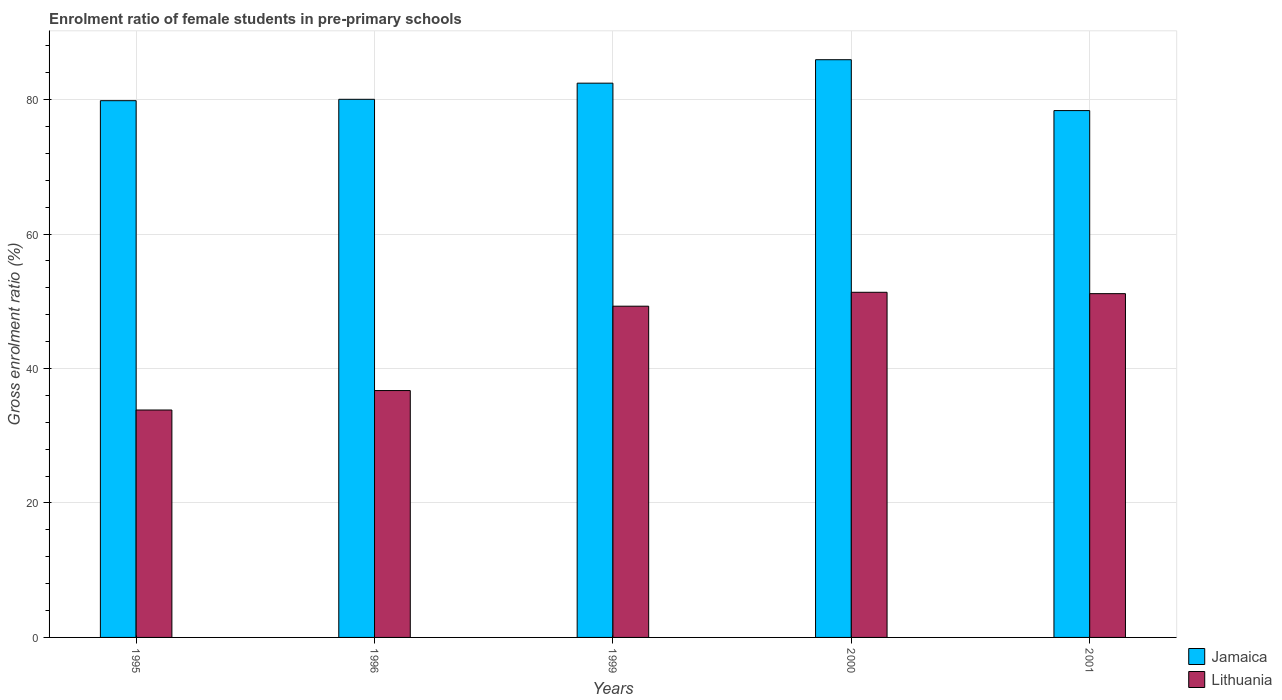How many groups of bars are there?
Offer a terse response. 5. Are the number of bars on each tick of the X-axis equal?
Offer a very short reply. Yes. How many bars are there on the 1st tick from the left?
Offer a terse response. 2. In how many cases, is the number of bars for a given year not equal to the number of legend labels?
Keep it short and to the point. 0. What is the enrolment ratio of female students in pre-primary schools in Lithuania in 1996?
Make the answer very short. 36.72. Across all years, what is the maximum enrolment ratio of female students in pre-primary schools in Jamaica?
Your response must be concise. 85.93. Across all years, what is the minimum enrolment ratio of female students in pre-primary schools in Lithuania?
Provide a short and direct response. 33.83. What is the total enrolment ratio of female students in pre-primary schools in Lithuania in the graph?
Give a very brief answer. 222.28. What is the difference between the enrolment ratio of female students in pre-primary schools in Lithuania in 1995 and that in 2000?
Give a very brief answer. -17.51. What is the difference between the enrolment ratio of female students in pre-primary schools in Jamaica in 2001 and the enrolment ratio of female students in pre-primary schools in Lithuania in 1996?
Offer a very short reply. 41.64. What is the average enrolment ratio of female students in pre-primary schools in Lithuania per year?
Ensure brevity in your answer.  44.46. In the year 1995, what is the difference between the enrolment ratio of female students in pre-primary schools in Jamaica and enrolment ratio of female students in pre-primary schools in Lithuania?
Provide a succinct answer. 46.01. In how many years, is the enrolment ratio of female students in pre-primary schools in Lithuania greater than 24 %?
Your answer should be very brief. 5. What is the ratio of the enrolment ratio of female students in pre-primary schools in Jamaica in 1995 to that in 1999?
Offer a very short reply. 0.97. What is the difference between the highest and the second highest enrolment ratio of female students in pre-primary schools in Jamaica?
Provide a succinct answer. 3.49. What is the difference between the highest and the lowest enrolment ratio of female students in pre-primary schools in Lithuania?
Your answer should be very brief. 17.51. In how many years, is the enrolment ratio of female students in pre-primary schools in Lithuania greater than the average enrolment ratio of female students in pre-primary schools in Lithuania taken over all years?
Provide a succinct answer. 3. Is the sum of the enrolment ratio of female students in pre-primary schools in Jamaica in 1996 and 1999 greater than the maximum enrolment ratio of female students in pre-primary schools in Lithuania across all years?
Your answer should be very brief. Yes. What does the 2nd bar from the left in 2001 represents?
Provide a succinct answer. Lithuania. What does the 1st bar from the right in 2000 represents?
Provide a succinct answer. Lithuania. Does the graph contain any zero values?
Your answer should be very brief. No. Does the graph contain grids?
Your answer should be very brief. Yes. Where does the legend appear in the graph?
Keep it short and to the point. Bottom right. How many legend labels are there?
Your answer should be very brief. 2. What is the title of the graph?
Ensure brevity in your answer.  Enrolment ratio of female students in pre-primary schools. What is the label or title of the X-axis?
Keep it short and to the point. Years. What is the Gross enrolment ratio (%) in Jamaica in 1995?
Offer a terse response. 79.83. What is the Gross enrolment ratio (%) in Lithuania in 1995?
Your answer should be compact. 33.83. What is the Gross enrolment ratio (%) of Jamaica in 1996?
Give a very brief answer. 80.04. What is the Gross enrolment ratio (%) in Lithuania in 1996?
Offer a very short reply. 36.72. What is the Gross enrolment ratio (%) of Jamaica in 1999?
Your answer should be compact. 82.44. What is the Gross enrolment ratio (%) of Lithuania in 1999?
Provide a short and direct response. 49.27. What is the Gross enrolment ratio (%) in Jamaica in 2000?
Your answer should be compact. 85.93. What is the Gross enrolment ratio (%) in Lithuania in 2000?
Ensure brevity in your answer.  51.34. What is the Gross enrolment ratio (%) in Jamaica in 2001?
Provide a succinct answer. 78.36. What is the Gross enrolment ratio (%) of Lithuania in 2001?
Your answer should be compact. 51.13. Across all years, what is the maximum Gross enrolment ratio (%) in Jamaica?
Your response must be concise. 85.93. Across all years, what is the maximum Gross enrolment ratio (%) of Lithuania?
Make the answer very short. 51.34. Across all years, what is the minimum Gross enrolment ratio (%) in Jamaica?
Your answer should be compact. 78.36. Across all years, what is the minimum Gross enrolment ratio (%) of Lithuania?
Ensure brevity in your answer.  33.83. What is the total Gross enrolment ratio (%) of Jamaica in the graph?
Give a very brief answer. 406.6. What is the total Gross enrolment ratio (%) of Lithuania in the graph?
Ensure brevity in your answer.  222.28. What is the difference between the Gross enrolment ratio (%) of Jamaica in 1995 and that in 1996?
Give a very brief answer. -0.21. What is the difference between the Gross enrolment ratio (%) of Lithuania in 1995 and that in 1996?
Offer a terse response. -2.89. What is the difference between the Gross enrolment ratio (%) in Jamaica in 1995 and that in 1999?
Your response must be concise. -2.6. What is the difference between the Gross enrolment ratio (%) in Lithuania in 1995 and that in 1999?
Ensure brevity in your answer.  -15.44. What is the difference between the Gross enrolment ratio (%) in Jamaica in 1995 and that in 2000?
Provide a short and direct response. -6.09. What is the difference between the Gross enrolment ratio (%) of Lithuania in 1995 and that in 2000?
Keep it short and to the point. -17.51. What is the difference between the Gross enrolment ratio (%) of Jamaica in 1995 and that in 2001?
Offer a terse response. 1.47. What is the difference between the Gross enrolment ratio (%) of Lithuania in 1995 and that in 2001?
Provide a short and direct response. -17.31. What is the difference between the Gross enrolment ratio (%) of Jamaica in 1996 and that in 1999?
Keep it short and to the point. -2.4. What is the difference between the Gross enrolment ratio (%) of Lithuania in 1996 and that in 1999?
Offer a terse response. -12.55. What is the difference between the Gross enrolment ratio (%) in Jamaica in 1996 and that in 2000?
Provide a succinct answer. -5.89. What is the difference between the Gross enrolment ratio (%) in Lithuania in 1996 and that in 2000?
Keep it short and to the point. -14.62. What is the difference between the Gross enrolment ratio (%) in Jamaica in 1996 and that in 2001?
Your answer should be very brief. 1.68. What is the difference between the Gross enrolment ratio (%) of Lithuania in 1996 and that in 2001?
Your answer should be compact. -14.42. What is the difference between the Gross enrolment ratio (%) of Jamaica in 1999 and that in 2000?
Provide a succinct answer. -3.49. What is the difference between the Gross enrolment ratio (%) of Lithuania in 1999 and that in 2000?
Offer a terse response. -2.07. What is the difference between the Gross enrolment ratio (%) in Jamaica in 1999 and that in 2001?
Make the answer very short. 4.08. What is the difference between the Gross enrolment ratio (%) in Lithuania in 1999 and that in 2001?
Offer a very short reply. -1.87. What is the difference between the Gross enrolment ratio (%) in Jamaica in 2000 and that in 2001?
Your answer should be very brief. 7.57. What is the difference between the Gross enrolment ratio (%) of Lithuania in 2000 and that in 2001?
Provide a succinct answer. 0.2. What is the difference between the Gross enrolment ratio (%) of Jamaica in 1995 and the Gross enrolment ratio (%) of Lithuania in 1996?
Provide a succinct answer. 43.12. What is the difference between the Gross enrolment ratio (%) of Jamaica in 1995 and the Gross enrolment ratio (%) of Lithuania in 1999?
Your response must be concise. 30.57. What is the difference between the Gross enrolment ratio (%) in Jamaica in 1995 and the Gross enrolment ratio (%) in Lithuania in 2000?
Ensure brevity in your answer.  28.5. What is the difference between the Gross enrolment ratio (%) in Jamaica in 1995 and the Gross enrolment ratio (%) in Lithuania in 2001?
Your response must be concise. 28.7. What is the difference between the Gross enrolment ratio (%) of Jamaica in 1996 and the Gross enrolment ratio (%) of Lithuania in 1999?
Your response must be concise. 30.77. What is the difference between the Gross enrolment ratio (%) of Jamaica in 1996 and the Gross enrolment ratio (%) of Lithuania in 2000?
Offer a very short reply. 28.7. What is the difference between the Gross enrolment ratio (%) in Jamaica in 1996 and the Gross enrolment ratio (%) in Lithuania in 2001?
Offer a very short reply. 28.91. What is the difference between the Gross enrolment ratio (%) of Jamaica in 1999 and the Gross enrolment ratio (%) of Lithuania in 2000?
Provide a short and direct response. 31.1. What is the difference between the Gross enrolment ratio (%) of Jamaica in 1999 and the Gross enrolment ratio (%) of Lithuania in 2001?
Make the answer very short. 31.3. What is the difference between the Gross enrolment ratio (%) of Jamaica in 2000 and the Gross enrolment ratio (%) of Lithuania in 2001?
Keep it short and to the point. 34.79. What is the average Gross enrolment ratio (%) of Jamaica per year?
Ensure brevity in your answer.  81.32. What is the average Gross enrolment ratio (%) in Lithuania per year?
Your response must be concise. 44.46. In the year 1995, what is the difference between the Gross enrolment ratio (%) in Jamaica and Gross enrolment ratio (%) in Lithuania?
Your answer should be compact. 46.01. In the year 1996, what is the difference between the Gross enrolment ratio (%) of Jamaica and Gross enrolment ratio (%) of Lithuania?
Provide a short and direct response. 43.32. In the year 1999, what is the difference between the Gross enrolment ratio (%) in Jamaica and Gross enrolment ratio (%) in Lithuania?
Your answer should be very brief. 33.17. In the year 2000, what is the difference between the Gross enrolment ratio (%) of Jamaica and Gross enrolment ratio (%) of Lithuania?
Keep it short and to the point. 34.59. In the year 2001, what is the difference between the Gross enrolment ratio (%) in Jamaica and Gross enrolment ratio (%) in Lithuania?
Your answer should be very brief. 27.23. What is the ratio of the Gross enrolment ratio (%) in Jamaica in 1995 to that in 1996?
Offer a very short reply. 1. What is the ratio of the Gross enrolment ratio (%) in Lithuania in 1995 to that in 1996?
Your answer should be very brief. 0.92. What is the ratio of the Gross enrolment ratio (%) of Jamaica in 1995 to that in 1999?
Offer a very short reply. 0.97. What is the ratio of the Gross enrolment ratio (%) of Lithuania in 1995 to that in 1999?
Keep it short and to the point. 0.69. What is the ratio of the Gross enrolment ratio (%) of Jamaica in 1995 to that in 2000?
Your response must be concise. 0.93. What is the ratio of the Gross enrolment ratio (%) in Lithuania in 1995 to that in 2000?
Provide a short and direct response. 0.66. What is the ratio of the Gross enrolment ratio (%) in Jamaica in 1995 to that in 2001?
Keep it short and to the point. 1.02. What is the ratio of the Gross enrolment ratio (%) of Lithuania in 1995 to that in 2001?
Offer a very short reply. 0.66. What is the ratio of the Gross enrolment ratio (%) in Jamaica in 1996 to that in 1999?
Your response must be concise. 0.97. What is the ratio of the Gross enrolment ratio (%) in Lithuania in 1996 to that in 1999?
Your answer should be very brief. 0.75. What is the ratio of the Gross enrolment ratio (%) of Jamaica in 1996 to that in 2000?
Your answer should be compact. 0.93. What is the ratio of the Gross enrolment ratio (%) in Lithuania in 1996 to that in 2000?
Your response must be concise. 0.72. What is the ratio of the Gross enrolment ratio (%) in Jamaica in 1996 to that in 2001?
Your response must be concise. 1.02. What is the ratio of the Gross enrolment ratio (%) in Lithuania in 1996 to that in 2001?
Provide a succinct answer. 0.72. What is the ratio of the Gross enrolment ratio (%) in Jamaica in 1999 to that in 2000?
Provide a succinct answer. 0.96. What is the ratio of the Gross enrolment ratio (%) in Lithuania in 1999 to that in 2000?
Offer a very short reply. 0.96. What is the ratio of the Gross enrolment ratio (%) of Jamaica in 1999 to that in 2001?
Offer a terse response. 1.05. What is the ratio of the Gross enrolment ratio (%) of Lithuania in 1999 to that in 2001?
Keep it short and to the point. 0.96. What is the ratio of the Gross enrolment ratio (%) of Jamaica in 2000 to that in 2001?
Make the answer very short. 1.1. What is the difference between the highest and the second highest Gross enrolment ratio (%) of Jamaica?
Your response must be concise. 3.49. What is the difference between the highest and the second highest Gross enrolment ratio (%) in Lithuania?
Offer a very short reply. 0.2. What is the difference between the highest and the lowest Gross enrolment ratio (%) in Jamaica?
Provide a short and direct response. 7.57. What is the difference between the highest and the lowest Gross enrolment ratio (%) of Lithuania?
Provide a succinct answer. 17.51. 